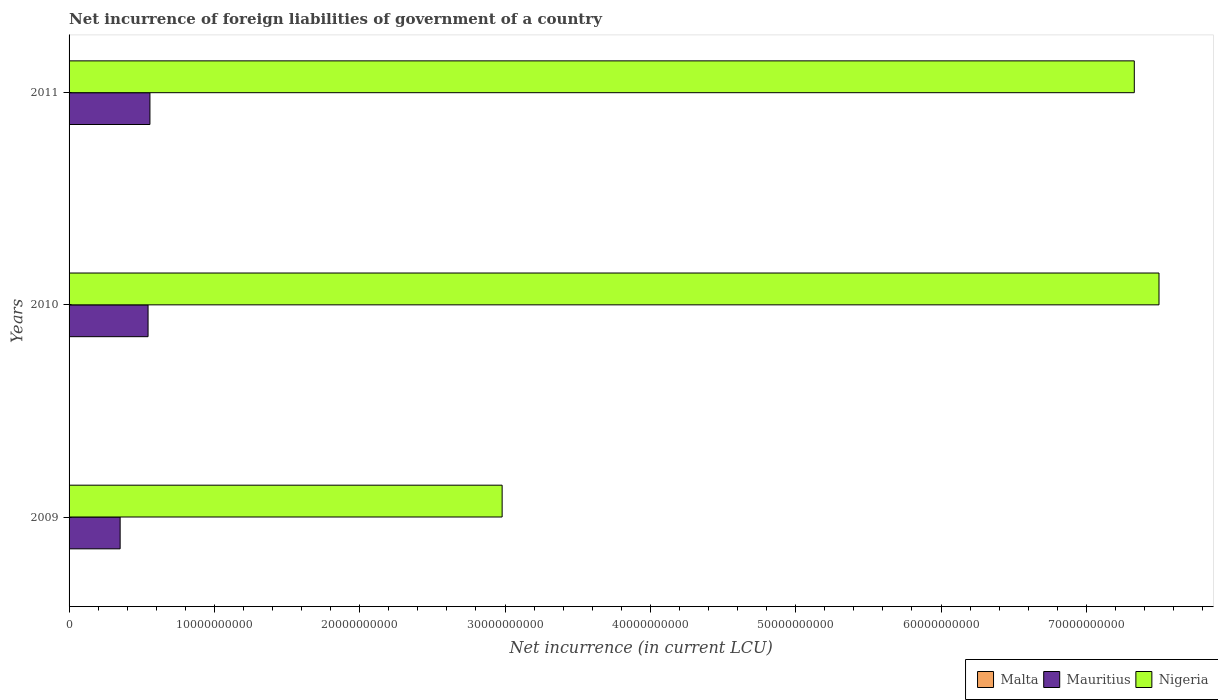How many groups of bars are there?
Keep it short and to the point. 3. Are the number of bars on each tick of the Y-axis equal?
Your answer should be compact. No. How many bars are there on the 2nd tick from the bottom?
Keep it short and to the point. 3. In how many cases, is the number of bars for a given year not equal to the number of legend labels?
Give a very brief answer. 1. What is the net incurrence of foreign liabilities in Malta in 2011?
Give a very brief answer. 2.34e+07. Across all years, what is the maximum net incurrence of foreign liabilities in Malta?
Provide a short and direct response. 2.34e+07. What is the total net incurrence of foreign liabilities in Mauritius in the graph?
Keep it short and to the point. 1.45e+1. What is the difference between the net incurrence of foreign liabilities in Malta in 2010 and that in 2011?
Ensure brevity in your answer.  -1.57e+07. What is the difference between the net incurrence of foreign liabilities in Malta in 2009 and the net incurrence of foreign liabilities in Mauritius in 2011?
Provide a short and direct response. -5.56e+09. What is the average net incurrence of foreign liabilities in Malta per year?
Ensure brevity in your answer.  1.04e+07. In the year 2011, what is the difference between the net incurrence of foreign liabilities in Nigeria and net incurrence of foreign liabilities in Malta?
Keep it short and to the point. 7.33e+1. In how many years, is the net incurrence of foreign liabilities in Nigeria greater than 24000000000 LCU?
Offer a very short reply. 3. What is the ratio of the net incurrence of foreign liabilities in Nigeria in 2009 to that in 2010?
Ensure brevity in your answer.  0.4. Is the net incurrence of foreign liabilities in Mauritius in 2010 less than that in 2011?
Provide a succinct answer. Yes. What is the difference between the highest and the second highest net incurrence of foreign liabilities in Nigeria?
Make the answer very short. 1.70e+09. What is the difference between the highest and the lowest net incurrence of foreign liabilities in Nigeria?
Your answer should be compact. 4.52e+1. In how many years, is the net incurrence of foreign liabilities in Mauritius greater than the average net incurrence of foreign liabilities in Mauritius taken over all years?
Ensure brevity in your answer.  2. Are all the bars in the graph horizontal?
Ensure brevity in your answer.  Yes. Are the values on the major ticks of X-axis written in scientific E-notation?
Your answer should be very brief. No. Does the graph contain grids?
Provide a short and direct response. No. Where does the legend appear in the graph?
Make the answer very short. Bottom right. How many legend labels are there?
Provide a succinct answer. 3. What is the title of the graph?
Give a very brief answer. Net incurrence of foreign liabilities of government of a country. Does "Kenya" appear as one of the legend labels in the graph?
Offer a terse response. No. What is the label or title of the X-axis?
Provide a succinct answer. Net incurrence (in current LCU). What is the label or title of the Y-axis?
Offer a very short reply. Years. What is the Net incurrence (in current LCU) in Malta in 2009?
Provide a succinct answer. 0. What is the Net incurrence (in current LCU) of Mauritius in 2009?
Keep it short and to the point. 3.51e+09. What is the Net incurrence (in current LCU) of Nigeria in 2009?
Provide a short and direct response. 2.98e+1. What is the Net incurrence (in current LCU) of Malta in 2010?
Make the answer very short. 7.68e+06. What is the Net incurrence (in current LCU) of Mauritius in 2010?
Offer a terse response. 5.44e+09. What is the Net incurrence (in current LCU) in Nigeria in 2010?
Ensure brevity in your answer.  7.50e+1. What is the Net incurrence (in current LCU) of Malta in 2011?
Give a very brief answer. 2.34e+07. What is the Net incurrence (in current LCU) of Mauritius in 2011?
Keep it short and to the point. 5.56e+09. What is the Net incurrence (in current LCU) in Nigeria in 2011?
Your response must be concise. 7.33e+1. Across all years, what is the maximum Net incurrence (in current LCU) of Malta?
Give a very brief answer. 2.34e+07. Across all years, what is the maximum Net incurrence (in current LCU) in Mauritius?
Your answer should be compact. 5.56e+09. Across all years, what is the maximum Net incurrence (in current LCU) in Nigeria?
Give a very brief answer. 7.50e+1. Across all years, what is the minimum Net incurrence (in current LCU) in Mauritius?
Your answer should be compact. 3.51e+09. Across all years, what is the minimum Net incurrence (in current LCU) of Nigeria?
Make the answer very short. 2.98e+1. What is the total Net incurrence (in current LCU) in Malta in the graph?
Provide a succinct answer. 3.11e+07. What is the total Net incurrence (in current LCU) of Mauritius in the graph?
Make the answer very short. 1.45e+1. What is the total Net incurrence (in current LCU) of Nigeria in the graph?
Provide a succinct answer. 1.78e+11. What is the difference between the Net incurrence (in current LCU) in Mauritius in 2009 and that in 2010?
Your response must be concise. -1.92e+09. What is the difference between the Net incurrence (in current LCU) of Nigeria in 2009 and that in 2010?
Provide a short and direct response. -4.52e+1. What is the difference between the Net incurrence (in current LCU) of Mauritius in 2009 and that in 2011?
Offer a very short reply. -2.05e+09. What is the difference between the Net incurrence (in current LCU) of Nigeria in 2009 and that in 2011?
Provide a succinct answer. -4.35e+1. What is the difference between the Net incurrence (in current LCU) in Malta in 2010 and that in 2011?
Ensure brevity in your answer.  -1.57e+07. What is the difference between the Net incurrence (in current LCU) of Mauritius in 2010 and that in 2011?
Offer a very short reply. -1.28e+08. What is the difference between the Net incurrence (in current LCU) in Nigeria in 2010 and that in 2011?
Keep it short and to the point. 1.70e+09. What is the difference between the Net incurrence (in current LCU) of Mauritius in 2009 and the Net incurrence (in current LCU) of Nigeria in 2010?
Keep it short and to the point. -7.15e+1. What is the difference between the Net incurrence (in current LCU) of Mauritius in 2009 and the Net incurrence (in current LCU) of Nigeria in 2011?
Your answer should be very brief. -6.98e+1. What is the difference between the Net incurrence (in current LCU) in Malta in 2010 and the Net incurrence (in current LCU) in Mauritius in 2011?
Keep it short and to the point. -5.56e+09. What is the difference between the Net incurrence (in current LCU) of Malta in 2010 and the Net incurrence (in current LCU) of Nigeria in 2011?
Provide a succinct answer. -7.33e+1. What is the difference between the Net incurrence (in current LCU) in Mauritius in 2010 and the Net incurrence (in current LCU) in Nigeria in 2011?
Keep it short and to the point. -6.79e+1. What is the average Net incurrence (in current LCU) in Malta per year?
Keep it short and to the point. 1.04e+07. What is the average Net incurrence (in current LCU) of Mauritius per year?
Provide a succinct answer. 4.84e+09. What is the average Net incurrence (in current LCU) of Nigeria per year?
Offer a terse response. 5.94e+1. In the year 2009, what is the difference between the Net incurrence (in current LCU) of Mauritius and Net incurrence (in current LCU) of Nigeria?
Offer a terse response. -2.63e+1. In the year 2010, what is the difference between the Net incurrence (in current LCU) of Malta and Net incurrence (in current LCU) of Mauritius?
Provide a short and direct response. -5.43e+09. In the year 2010, what is the difference between the Net incurrence (in current LCU) in Malta and Net incurrence (in current LCU) in Nigeria?
Make the answer very short. -7.50e+1. In the year 2010, what is the difference between the Net incurrence (in current LCU) in Mauritius and Net incurrence (in current LCU) in Nigeria?
Provide a succinct answer. -6.96e+1. In the year 2011, what is the difference between the Net incurrence (in current LCU) in Malta and Net incurrence (in current LCU) in Mauritius?
Keep it short and to the point. -5.54e+09. In the year 2011, what is the difference between the Net incurrence (in current LCU) of Malta and Net incurrence (in current LCU) of Nigeria?
Your answer should be compact. -7.33e+1. In the year 2011, what is the difference between the Net incurrence (in current LCU) of Mauritius and Net incurrence (in current LCU) of Nigeria?
Your answer should be very brief. -6.77e+1. What is the ratio of the Net incurrence (in current LCU) in Mauritius in 2009 to that in 2010?
Ensure brevity in your answer.  0.65. What is the ratio of the Net incurrence (in current LCU) of Nigeria in 2009 to that in 2010?
Keep it short and to the point. 0.4. What is the ratio of the Net incurrence (in current LCU) of Mauritius in 2009 to that in 2011?
Provide a short and direct response. 0.63. What is the ratio of the Net incurrence (in current LCU) in Nigeria in 2009 to that in 2011?
Give a very brief answer. 0.41. What is the ratio of the Net incurrence (in current LCU) of Malta in 2010 to that in 2011?
Give a very brief answer. 0.33. What is the ratio of the Net incurrence (in current LCU) in Mauritius in 2010 to that in 2011?
Provide a short and direct response. 0.98. What is the ratio of the Net incurrence (in current LCU) of Nigeria in 2010 to that in 2011?
Make the answer very short. 1.02. What is the difference between the highest and the second highest Net incurrence (in current LCU) of Mauritius?
Give a very brief answer. 1.28e+08. What is the difference between the highest and the second highest Net incurrence (in current LCU) of Nigeria?
Offer a terse response. 1.70e+09. What is the difference between the highest and the lowest Net incurrence (in current LCU) in Malta?
Provide a short and direct response. 2.34e+07. What is the difference between the highest and the lowest Net incurrence (in current LCU) of Mauritius?
Make the answer very short. 2.05e+09. What is the difference between the highest and the lowest Net incurrence (in current LCU) of Nigeria?
Ensure brevity in your answer.  4.52e+1. 